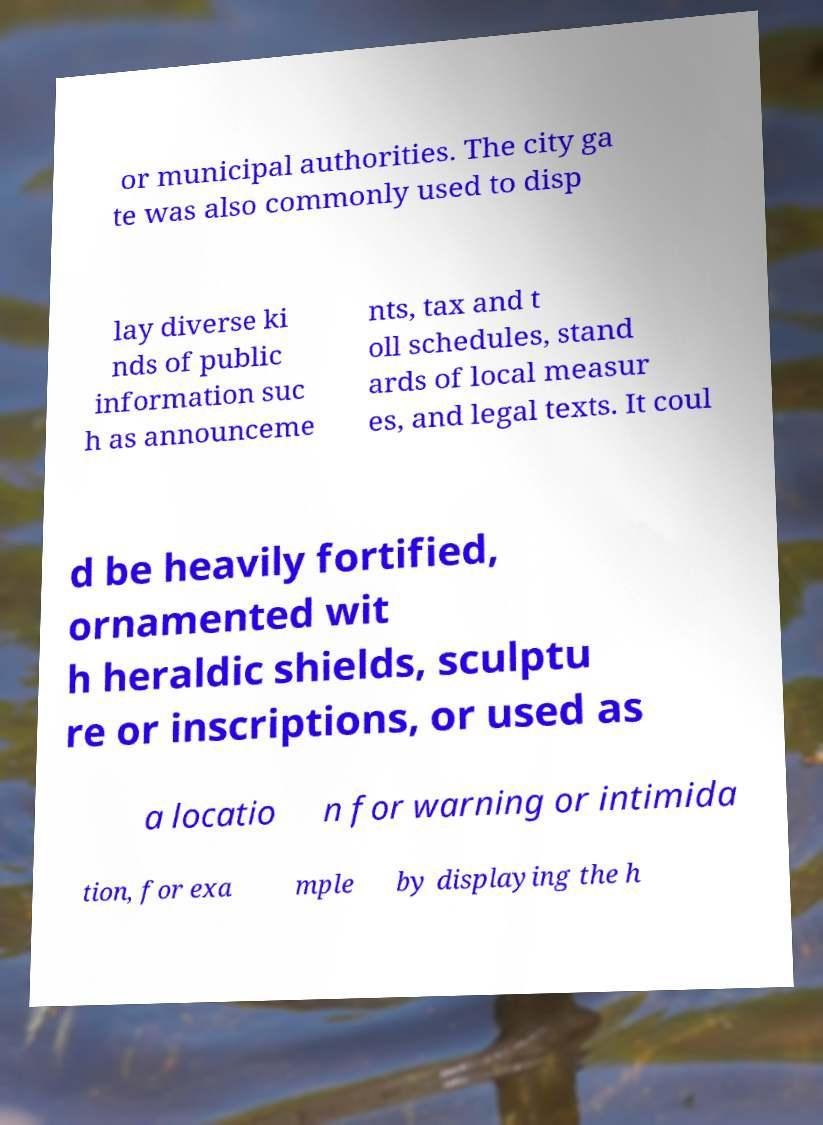Can you accurately transcribe the text from the provided image for me? or municipal authorities. The city ga te was also commonly used to disp lay diverse ki nds of public information suc h as announceme nts, tax and t oll schedules, stand ards of local measur es, and legal texts. It coul d be heavily fortified, ornamented wit h heraldic shields, sculptu re or inscriptions, or used as a locatio n for warning or intimida tion, for exa mple by displaying the h 